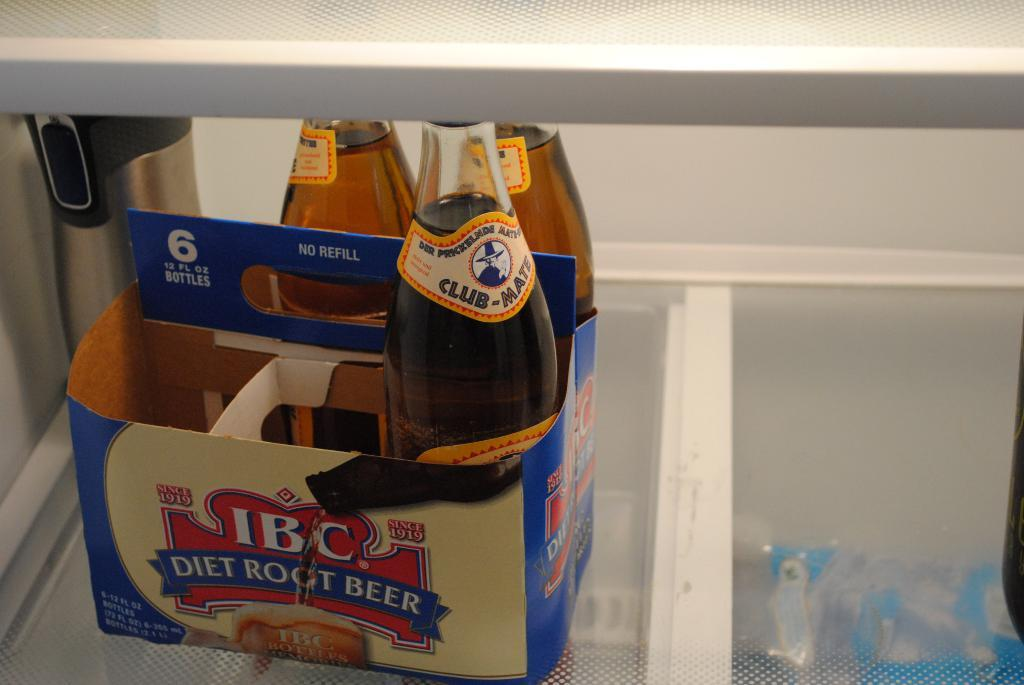<image>
Render a clear and concise summary of the photo. Three bottles of IBC Diet Root Beer make up half of a six pack. 